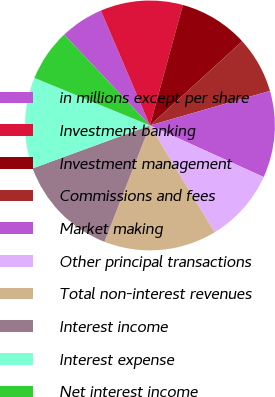Convert chart. <chart><loc_0><loc_0><loc_500><loc_500><pie_chart><fcel>in millions except per share<fcel>Investment banking<fcel>Investment management<fcel>Commissions and fees<fcel>Market making<fcel>Other principal transactions<fcel>Total non-interest revenues<fcel>Interest income<fcel>Interest expense<fcel>Net interest income<nl><fcel>5.62%<fcel>10.67%<fcel>8.99%<fcel>7.3%<fcel>11.24%<fcel>9.55%<fcel>14.61%<fcel>13.48%<fcel>11.8%<fcel>6.74%<nl></chart> 